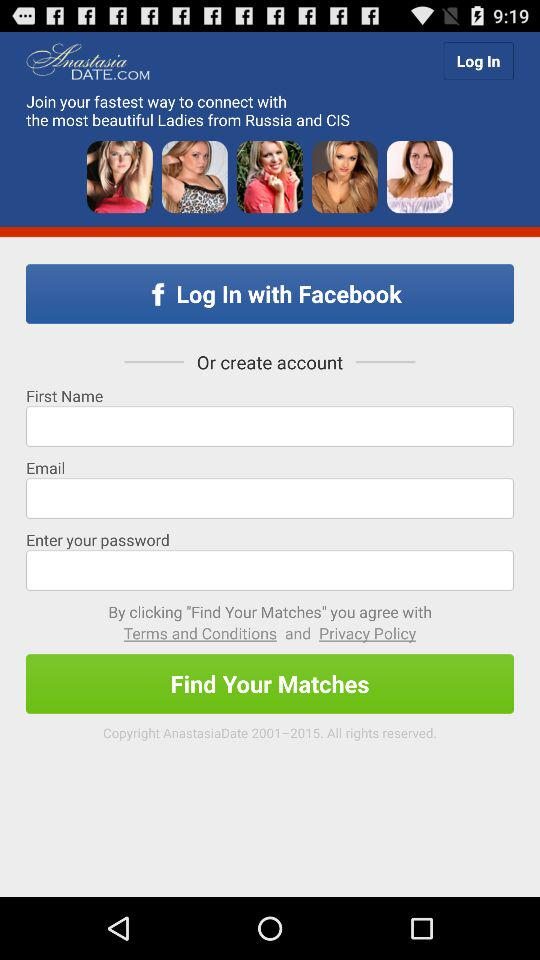What applications can we log into? The application is "Facebook". 